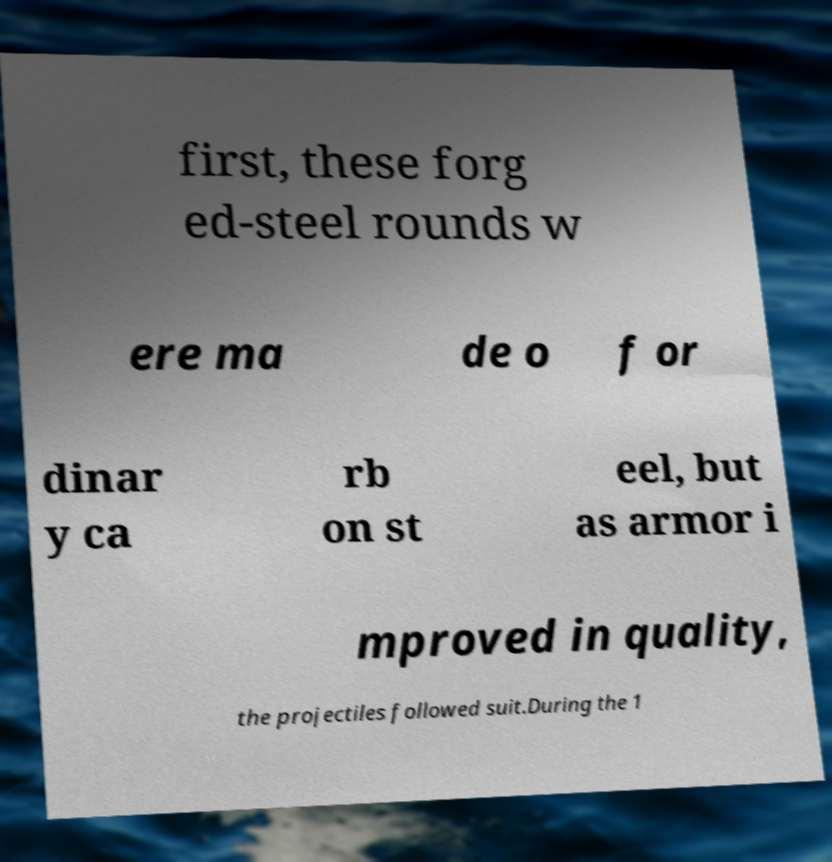Could you extract and type out the text from this image? first, these forg ed-steel rounds w ere ma de o f or dinar y ca rb on st eel, but as armor i mproved in quality, the projectiles followed suit.During the 1 